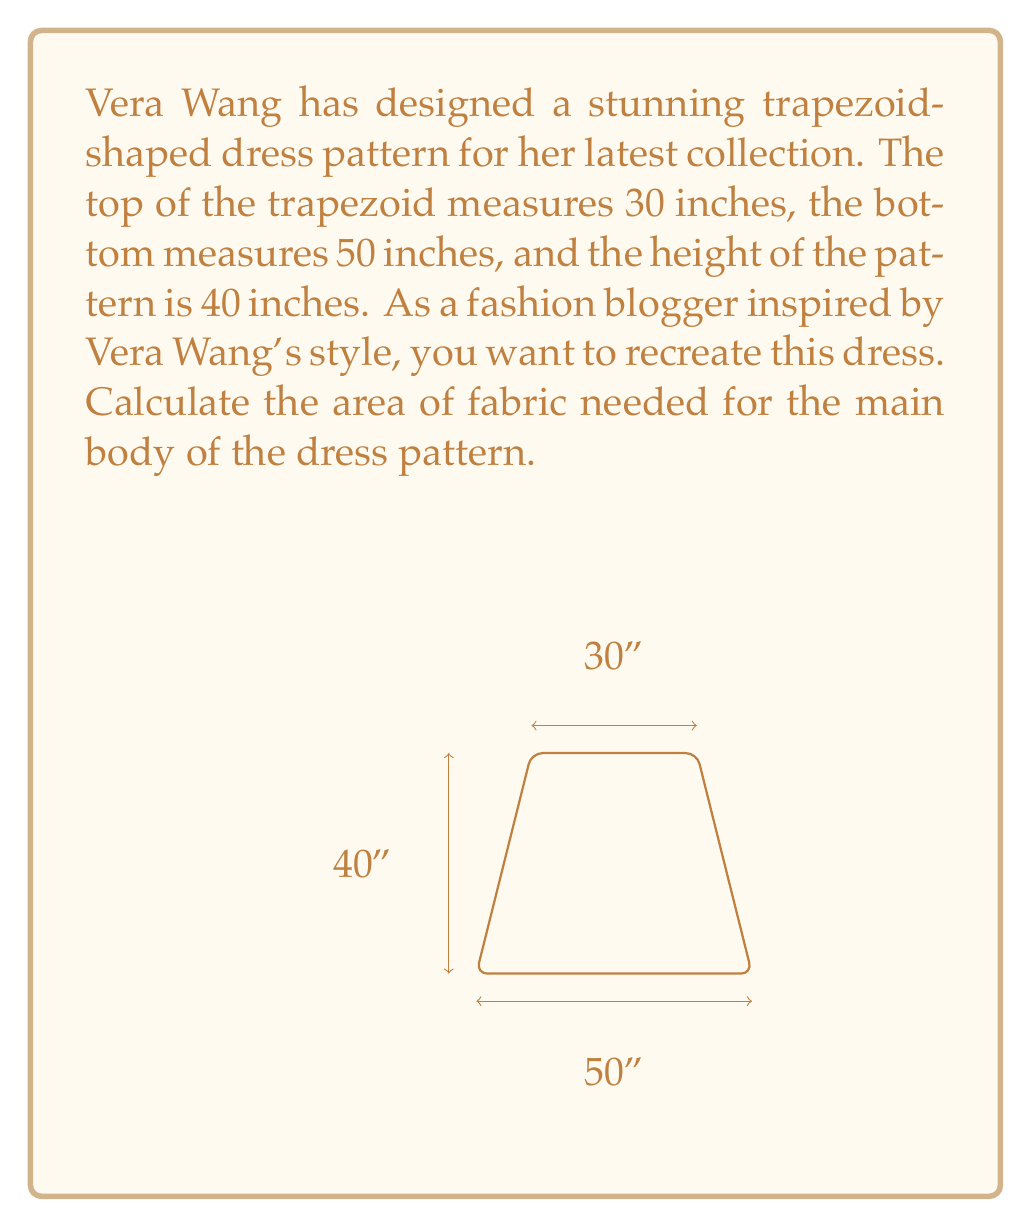Provide a solution to this math problem. To calculate the area of a trapezoid-shaped dress pattern, we'll use the formula for the area of a trapezoid:

$$ A = \frac{1}{2}(b_1 + b_2)h $$

Where:
$A$ = Area of the trapezoid
$b_1$ = Length of one parallel side (top of the dress pattern)
$b_2$ = Length of the other parallel side (bottom of the dress pattern)
$h$ = Height of the trapezoid (length of the dress pattern)

Given:
$b_1 = 30$ inches (top of the dress pattern)
$b_2 = 50$ inches (bottom of the dress pattern)
$h = 40$ inches (height of the dress pattern)

Let's substitute these values into the formula:

$$ A = \frac{1}{2}(30 + 50) \times 40 $$

First, add the parallel sides:
$$ A = \frac{1}{2}(80) \times 40 $$

Multiply:
$$ A = 40 \times 40 $$

$$ A = 1600 $$

Therefore, the area of the trapezoid-shaped dress pattern is 1600 square inches.
Answer: The area of the trapezoid-shaped dress pattern is 1600 square inches. 